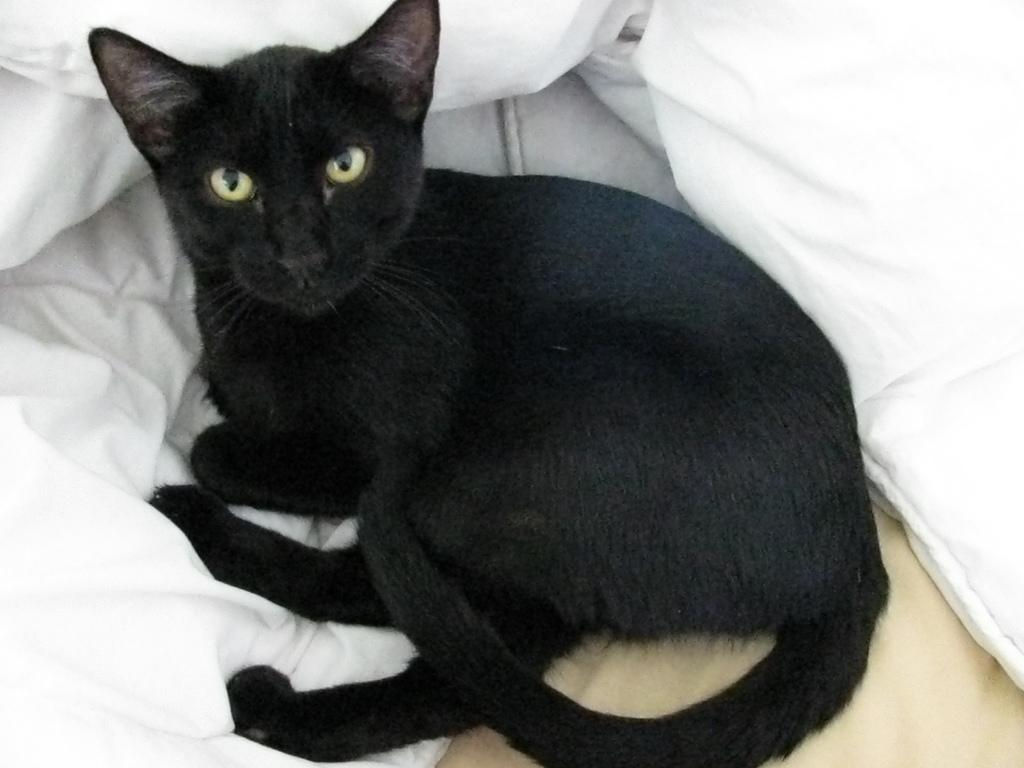What type of animal is in the image? There is a black color cat in the image. Where is the cat located? The cat is on the bed. What color is the blanket on the bed? There is a white blanket in the image. How many giants can be seen in the image? There are no giants present in the image. What type of boot is the cat wearing in the image? The cat is not wearing any boots in the image. 